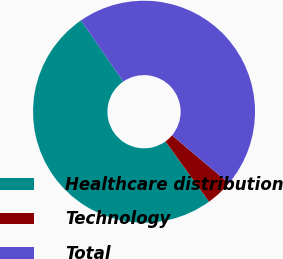Convert chart. <chart><loc_0><loc_0><loc_500><loc_500><pie_chart><fcel>Healthcare distribution<fcel>Technology<fcel>Total<nl><fcel>50.34%<fcel>3.89%<fcel>45.76%<nl></chart> 